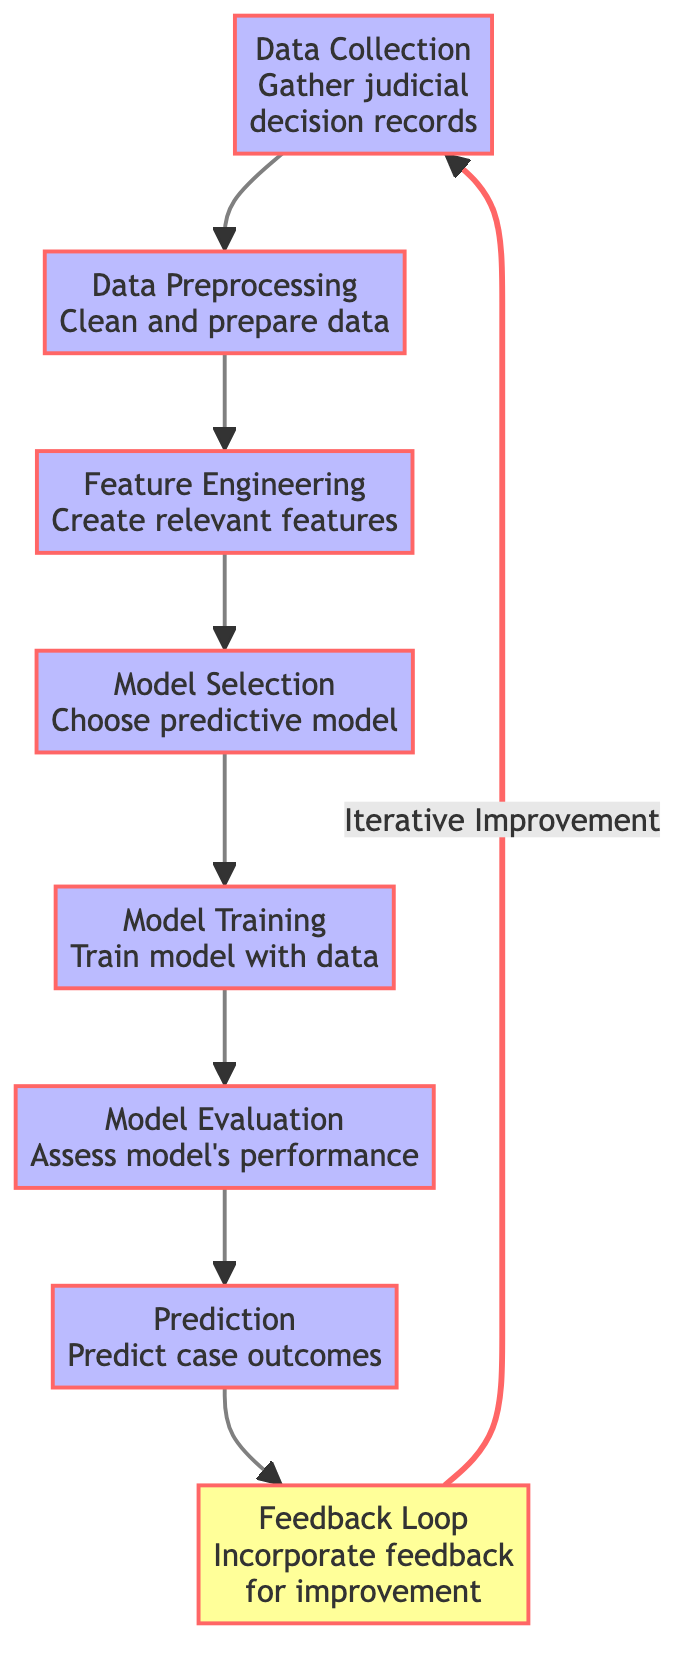What step follows data preprocessing? In the diagram, after the node for Data Preprocessing, the next node indicated is Feature Engineering, which involves creating relevant features from the cleaned data.
Answer: Feature Engineering How many main steps are there in the process? The diagram outlines a total of seven main steps, which are sequentially linked from data collection to prediction.
Answer: Seven What is the output of the model evaluation step? The output of Model Evaluation is an assessment of the model's performance, determining how well the model predicts outcomes based on the training phase.
Answer: Assess model's performance In which step is the predictive model chosen? The predictive model is selected in the Model Selection step, as indicated in the diagram which occurs after Feature Engineering.
Answer: Model Selection What initiates the feedback loop? The Feedback Loop is initiated after making predictions, where feedback is gathered to incorporate improvements into the data collection phase.
Answer: Prediction What connects feedback loop to data collection? The connection between the Feedback Loop and Data Collection is labeled "Iterative Improvement," which suggests that the feedback is used to enhance future models.
Answer: Iterative Improvement How many decision nodes are shown in the diagram? There is only one decision node, which is the Feedback Loop, as it incorporates feedback for improvement and connects back to Data Collection.
Answer: One What is the first step in the predictive analysis process? The first step, as shown in the diagram, is Data Collection which involves gathering judicial decision records to prepare for further analysis.
Answer: Data Collection Which step evaluates the performance of the model? The step that evaluates the performance of the model is Model Evaluation, where the efficacy of the trained model is assessed against specific metrics.
Answer: Model Evaluation 